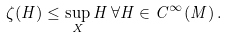Convert formula to latex. <formula><loc_0><loc_0><loc_500><loc_500>\zeta ( H ) \leq \sup _ { X } H \, \forall H \in C ^ { \infty } ( M ) \, .</formula> 